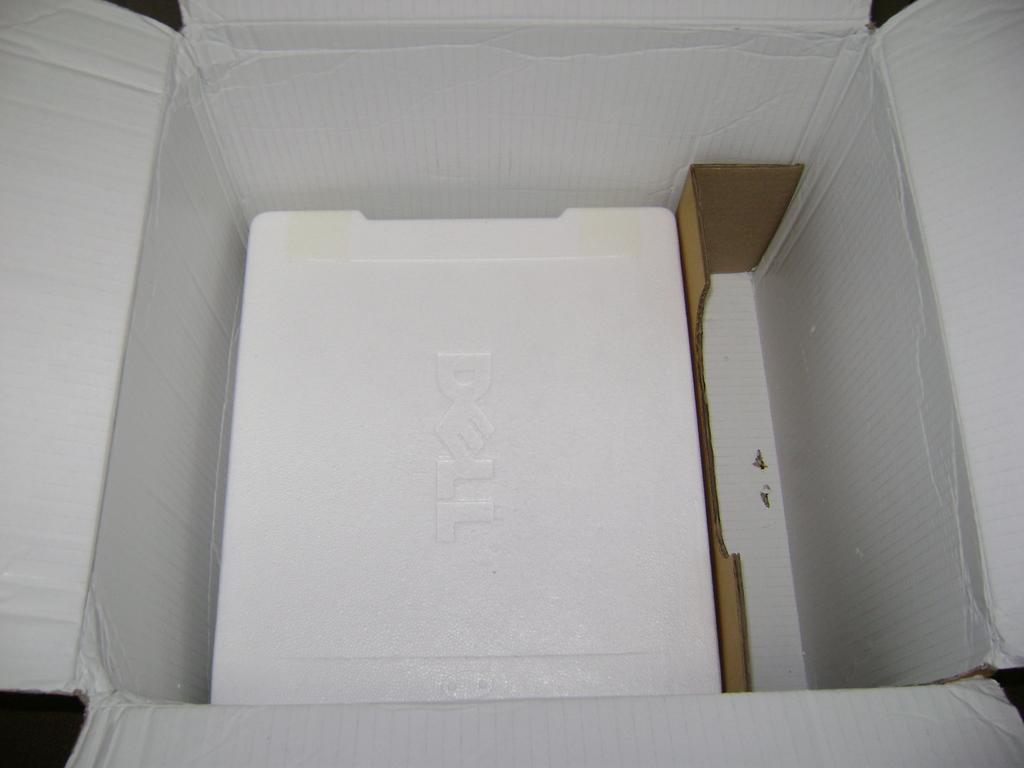<image>
Present a compact description of the photo's key features. white dell computer box is left open nothing inside 